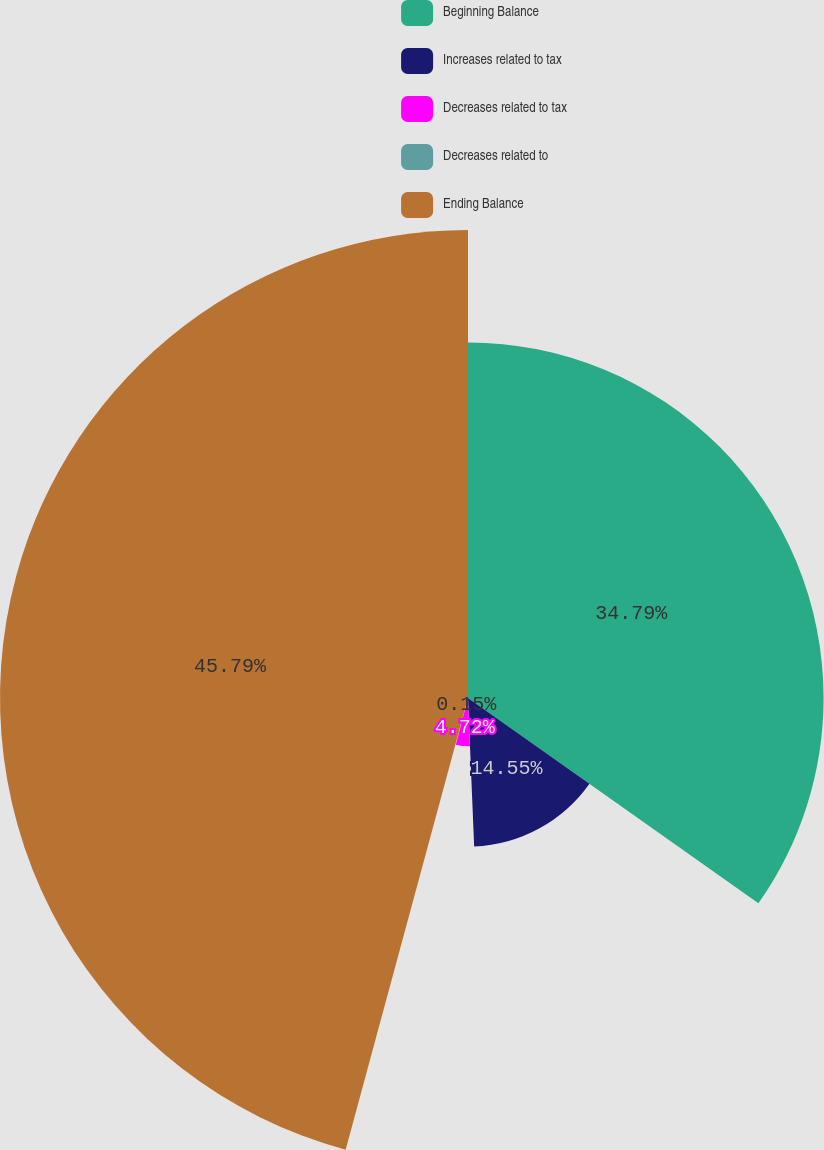Convert chart. <chart><loc_0><loc_0><loc_500><loc_500><pie_chart><fcel>Beginning Balance<fcel>Increases related to tax<fcel>Decreases related to tax<fcel>Decreases related to<fcel>Ending Balance<nl><fcel>34.79%<fcel>14.55%<fcel>4.72%<fcel>0.15%<fcel>45.79%<nl></chart> 